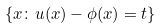<formula> <loc_0><loc_0><loc_500><loc_500>\{ x \colon u ( x ) - \phi ( x ) = t \}</formula> 